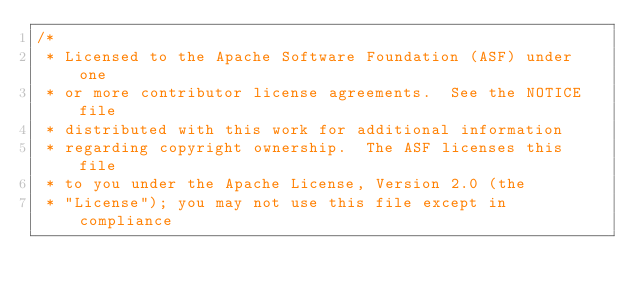<code> <loc_0><loc_0><loc_500><loc_500><_Java_>/*
 * Licensed to the Apache Software Foundation (ASF) under one
 * or more contributor license agreements.  See the NOTICE file
 * distributed with this work for additional information
 * regarding copyright ownership.  The ASF licenses this file
 * to you under the Apache License, Version 2.0 (the
 * "License"); you may not use this file except in compliance</code> 